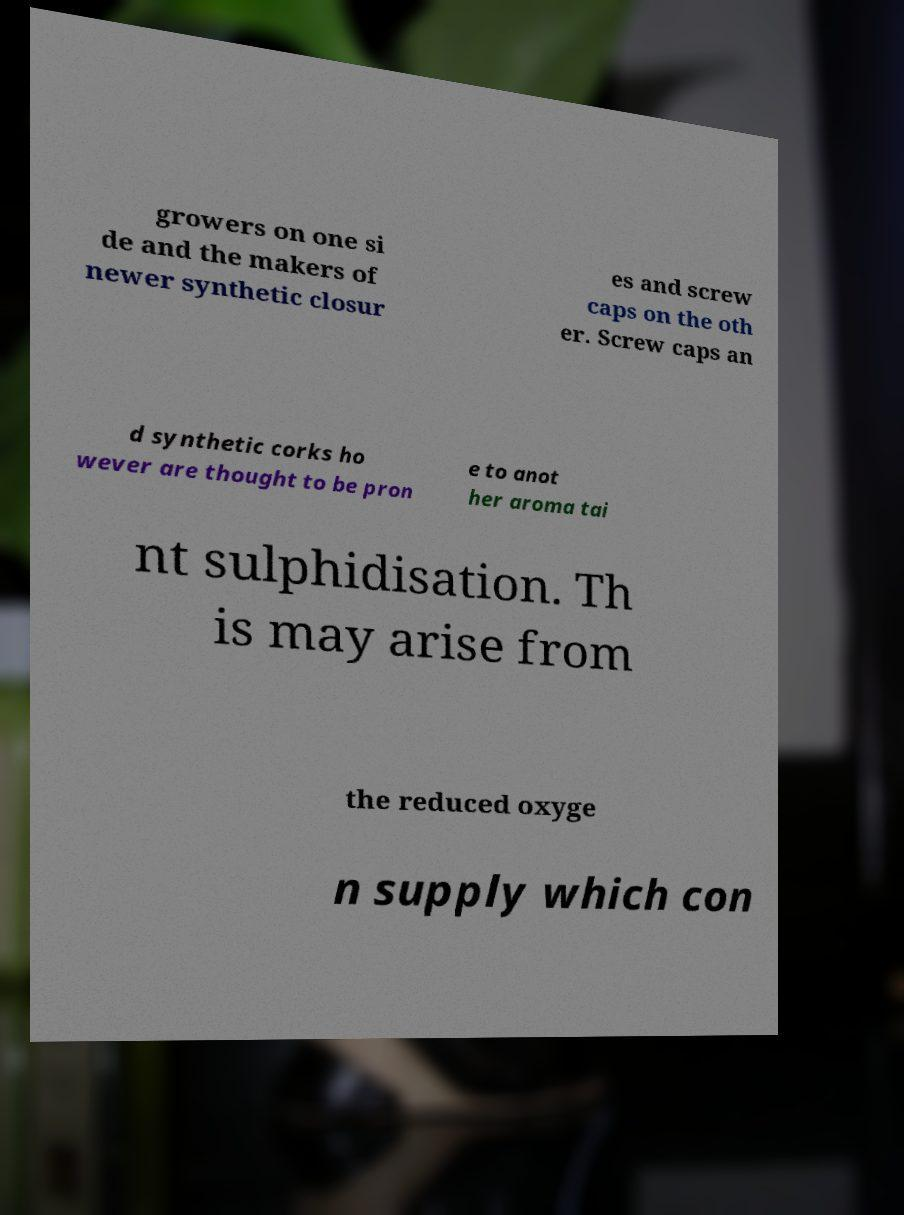For documentation purposes, I need the text within this image transcribed. Could you provide that? growers on one si de and the makers of newer synthetic closur es and screw caps on the oth er. Screw caps an d synthetic corks ho wever are thought to be pron e to anot her aroma tai nt sulphidisation. Th is may arise from the reduced oxyge n supply which con 